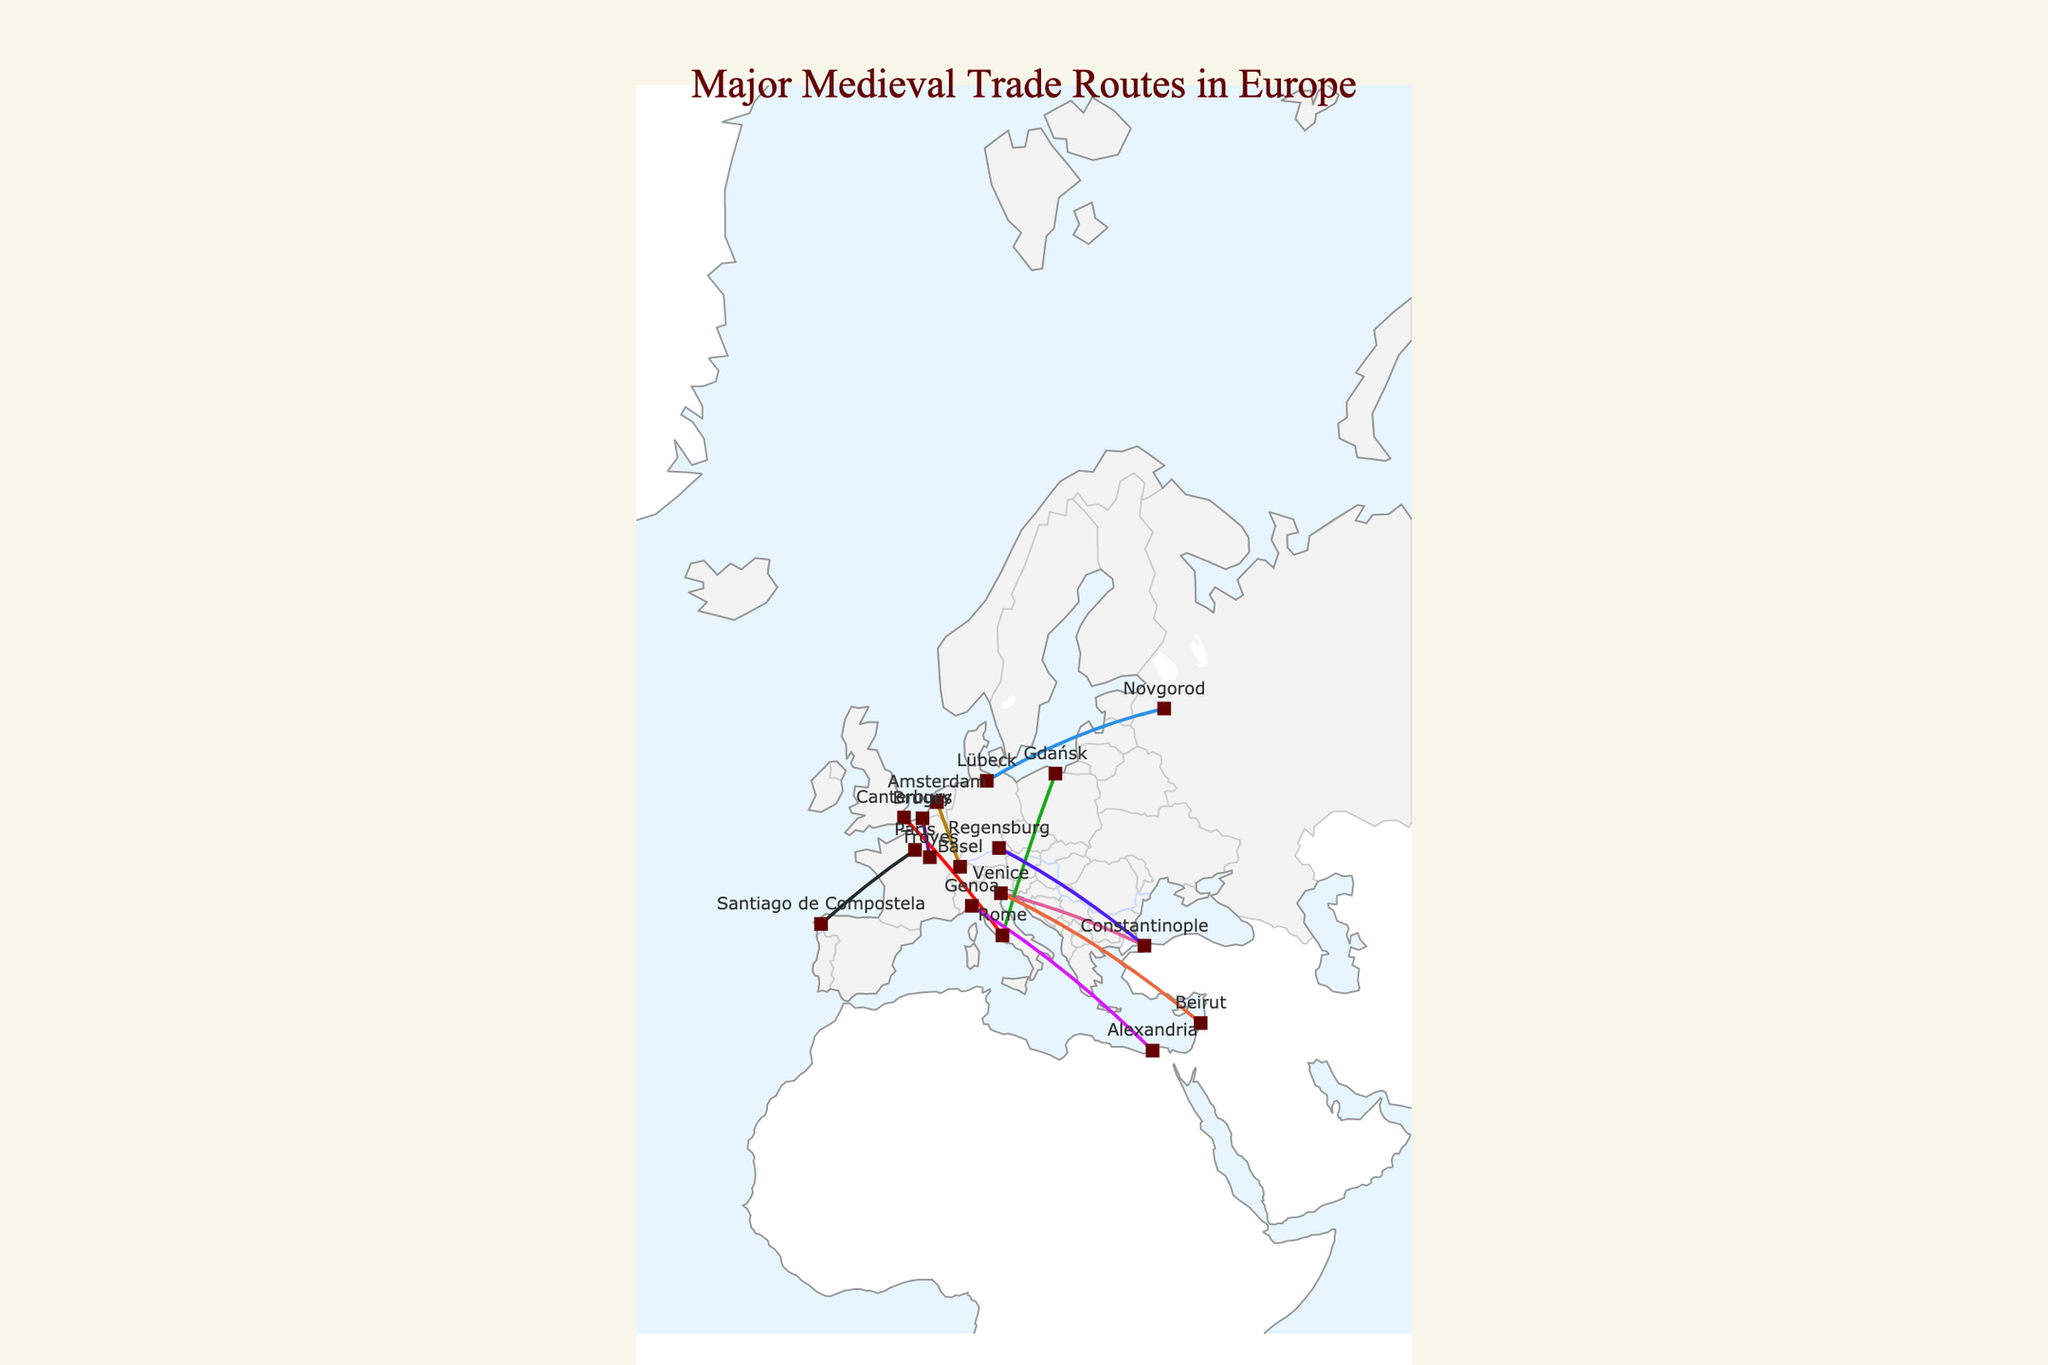What's the title of the figure? The title is usually displayed prominently at the top of the figure. Here, it is found positioned centrally.
Answer: Major Medieval Trade Routes in Europe Which trade route starts from Lübeck? Locate Lübeck on the map, and you will see that the only route starting from there is the Hanseatic League Route.
Answer: Hanseatic League Route Which trade route has the highest Cultural Exchange Score and what is that score? By looking at the text hover information for each route, you can identify the scores. The highest score is 9, shared by the Silk Road (European Section), Mediterranean Sea Route, and Venetian Trade Route.
Answer: Silk Road (European Section), Mediterranean Sea Route, Venetian Trade Route, 9 How many cities are marked on the map? The cities are represented by markers with text labels. By counting them on the map, you can find there are multiple unique cities.
Answer: 15 Between which two cities does the Amber Road run? By following the route starting and ending points on the map, you can see that the Amber Road runs between Gdańsk and Rome.
Answer: Gdańsk and Rome Which trade route is the longest distance based on visible geographic span? This requires estimating the length based on the geographic span shown on the map. The visible distance from Constantinople (modern-day Istanbul) to Venice for the Silk Road (European Section) appears to be one of the longest.
Answer: Silk Road (European Section) Which trade route connects two cities within modern-day Italy? By locating Genoa, Venice, and other Italian cities on the map, you see that the Venetian Trade Route runs within modern-day Italy's borders.
Answer: Venetian Trade Route What is the common end city for both the Via Francigena and the Amber Road? Identifying the end points on the map for both routes shows the common end city is Rome.
Answer: Rome Between Paris and Santiago de Compostela, which trade route spans this journey? By tracking the connection line between these two cities, you can identify the Camino de Santiago.
Answer: Camino de Santiago What is the Cultural Exchange Score of the Champagne Fairs Route? Checking the text hover information related to the Champagne Fairs Route will show the Cultural Exchange Score.
Answer: 8 Which city appears to be a central hub being a part of multiple trade routes? Observing the map, you see that Venice appears to be part of several routes, indicating its importance as a central hub.
Answer: Venice 